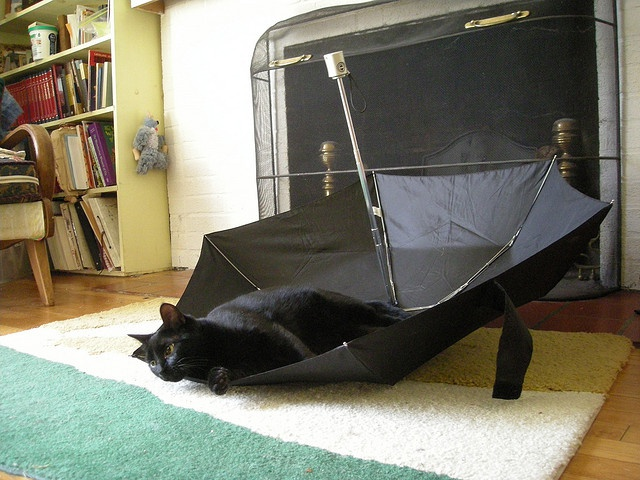Describe the objects in this image and their specific colors. I can see umbrella in olive, black, and gray tones, book in olive, tan, maroon, and black tones, cat in olive, black, and gray tones, chair in olive, tan, black, and maroon tones, and book in olive and tan tones in this image. 